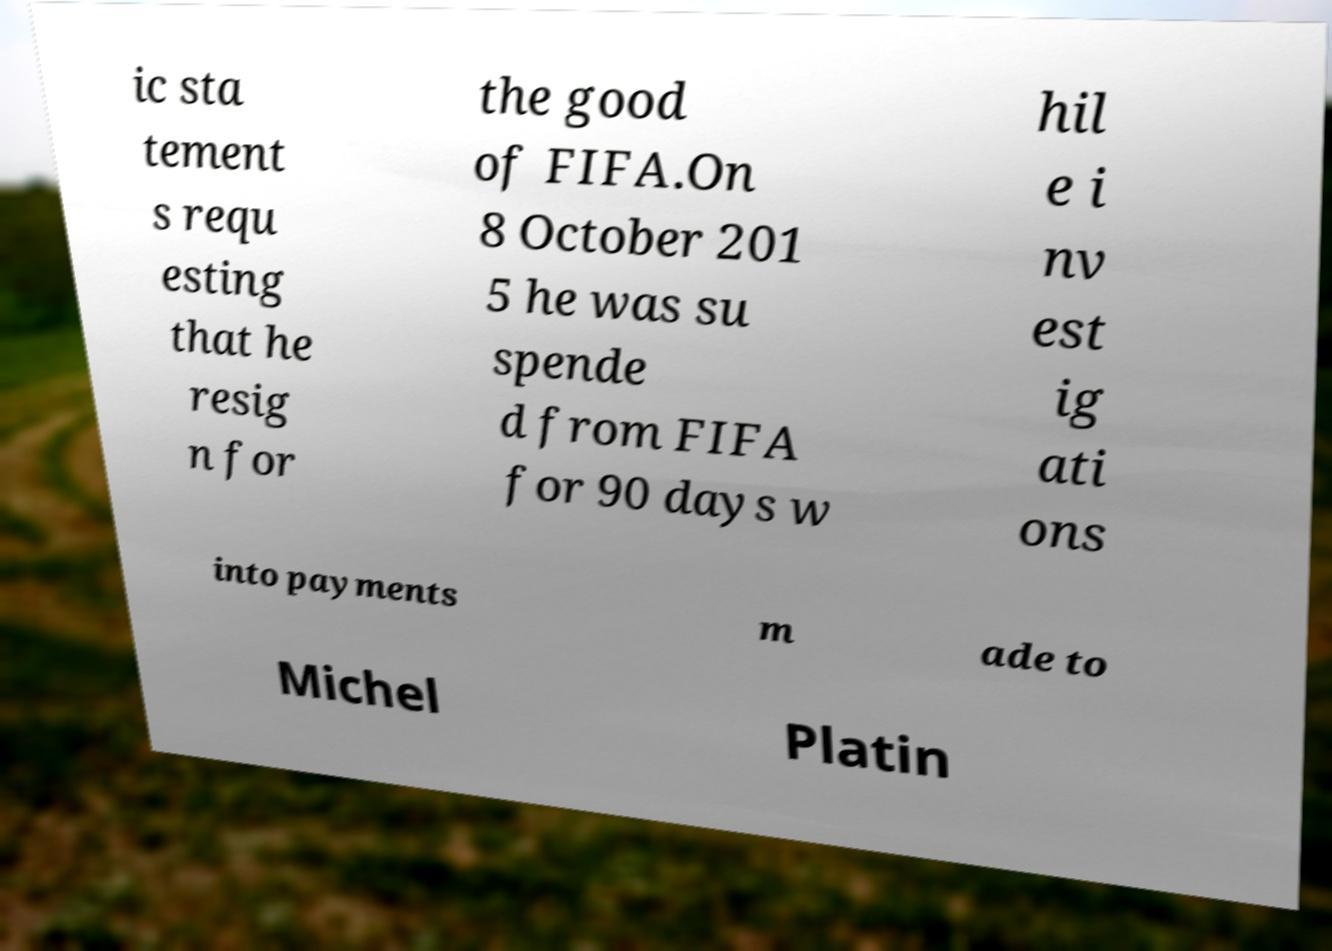Could you assist in decoding the text presented in this image and type it out clearly? ic sta tement s requ esting that he resig n for the good of FIFA.On 8 October 201 5 he was su spende d from FIFA for 90 days w hil e i nv est ig ati ons into payments m ade to Michel Platin 